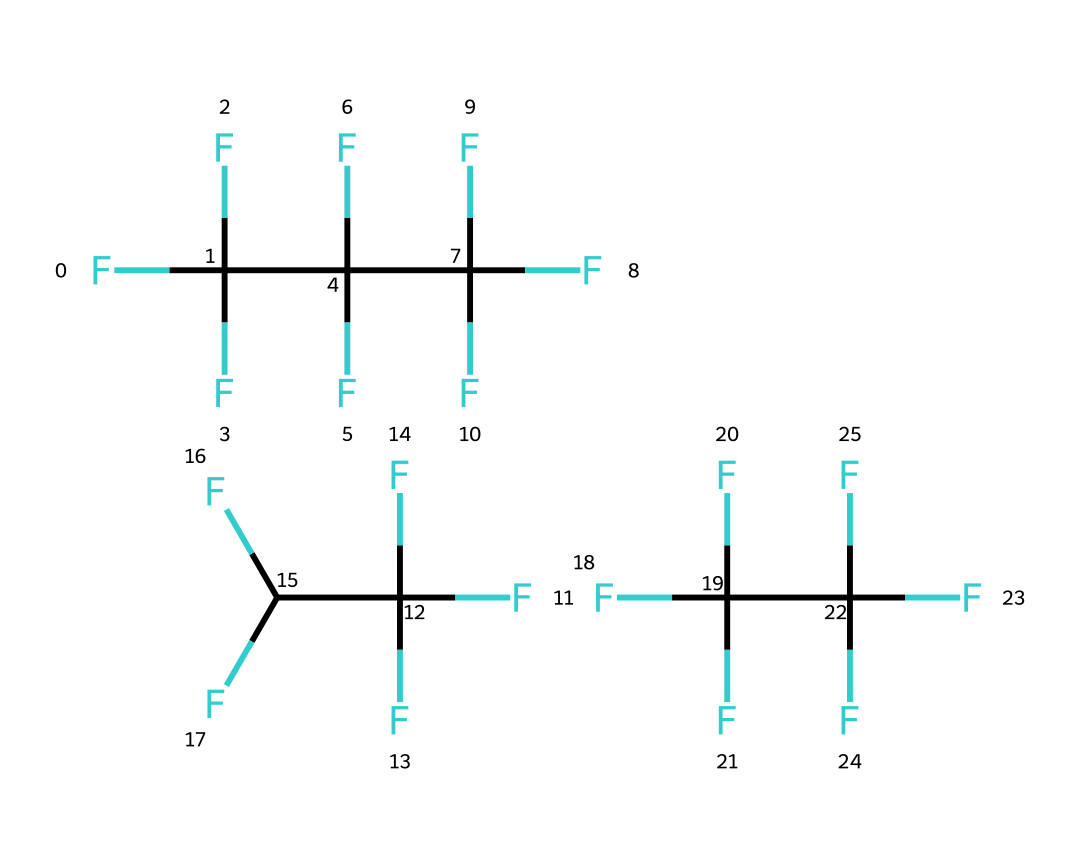What is the main type of this chemical? The chemical is a refrigerant, identified by the presence of fluorinated compounds commonly used to absorb heat and provide cooling in systems such as portable medical coolers.
Answer: refrigerant How many carbon atoms are in R-404A? By analyzing the structure, we can count the number of carbon atoms present in the SMILES representation, which indicates there are four carbon atoms in this refrigerant blend.
Answer: 4 What is the common application of R-404A? This refrigerant is typically used in portable medical coolers, which require efficient heat transfer and temperature control to maintain the effectiveness of stored medical supplies.
Answer: portable medical coolers How many fluorine atoms are present in the molecule? The SMILES notation reveals multiple groups of fluorinated carbon atoms; counting each fluorine indicator (F) shows there are 12 fluorine atoms total in the structure.
Answer: 12 Is R-404A an environmentally friendly refrigerant? R-404A is considered less environmentally friendly due to its high global warming potential and contribution to greenhouse gas emissions, which raises concerns about its impact on climate change.
Answer: no What type of bonds are present in R-404A? The SMILES representation suggests that the chemical structure contains carbon-fluorine bonds and carbon-carbon bonds, which are characteristic of its composition and behaviour as a refrigerant.
Answer: carbon-fluorine and carbon-carbon bonds 